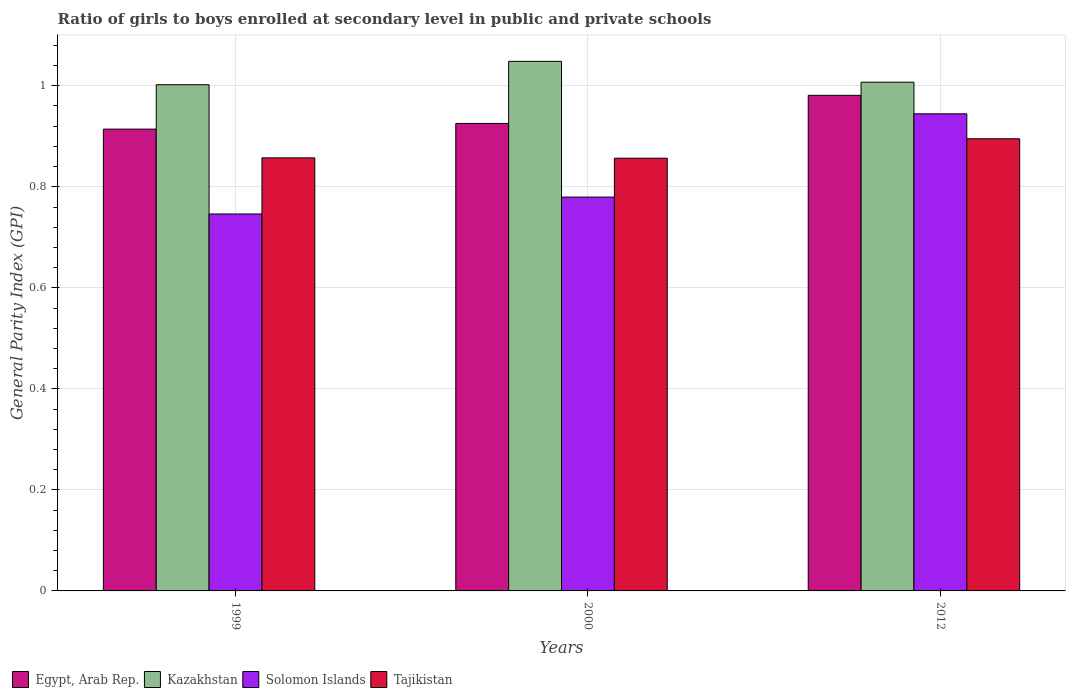Are the number of bars on each tick of the X-axis equal?
Offer a very short reply. Yes. What is the general parity index in Tajikistan in 2000?
Offer a very short reply. 0.86. Across all years, what is the maximum general parity index in Egypt, Arab Rep.?
Give a very brief answer. 0.98. Across all years, what is the minimum general parity index in Tajikistan?
Give a very brief answer. 0.86. In which year was the general parity index in Kazakhstan maximum?
Provide a short and direct response. 2000. In which year was the general parity index in Solomon Islands minimum?
Your response must be concise. 1999. What is the total general parity index in Tajikistan in the graph?
Your answer should be compact. 2.61. What is the difference between the general parity index in Egypt, Arab Rep. in 2000 and that in 2012?
Provide a succinct answer. -0.06. What is the difference between the general parity index in Egypt, Arab Rep. in 2000 and the general parity index in Solomon Islands in 1999?
Provide a short and direct response. 0.18. What is the average general parity index in Tajikistan per year?
Ensure brevity in your answer.  0.87. In the year 2000, what is the difference between the general parity index in Solomon Islands and general parity index in Tajikistan?
Offer a terse response. -0.08. What is the ratio of the general parity index in Egypt, Arab Rep. in 2000 to that in 2012?
Offer a very short reply. 0.94. Is the difference between the general parity index in Solomon Islands in 1999 and 2000 greater than the difference between the general parity index in Tajikistan in 1999 and 2000?
Your answer should be compact. No. What is the difference between the highest and the second highest general parity index in Tajikistan?
Ensure brevity in your answer.  0.04. What is the difference between the highest and the lowest general parity index in Solomon Islands?
Keep it short and to the point. 0.2. In how many years, is the general parity index in Kazakhstan greater than the average general parity index in Kazakhstan taken over all years?
Provide a succinct answer. 1. Is the sum of the general parity index in Tajikistan in 1999 and 2012 greater than the maximum general parity index in Solomon Islands across all years?
Provide a succinct answer. Yes. What does the 2nd bar from the left in 2000 represents?
Offer a very short reply. Kazakhstan. What does the 3rd bar from the right in 2012 represents?
Make the answer very short. Kazakhstan. Is it the case that in every year, the sum of the general parity index in Egypt, Arab Rep. and general parity index in Solomon Islands is greater than the general parity index in Kazakhstan?
Provide a succinct answer. Yes. Are the values on the major ticks of Y-axis written in scientific E-notation?
Offer a very short reply. No. Where does the legend appear in the graph?
Keep it short and to the point. Bottom left. How many legend labels are there?
Give a very brief answer. 4. How are the legend labels stacked?
Give a very brief answer. Horizontal. What is the title of the graph?
Your answer should be very brief. Ratio of girls to boys enrolled at secondary level in public and private schools. Does "Nepal" appear as one of the legend labels in the graph?
Ensure brevity in your answer.  No. What is the label or title of the X-axis?
Provide a succinct answer. Years. What is the label or title of the Y-axis?
Offer a terse response. General Parity Index (GPI). What is the General Parity Index (GPI) of Egypt, Arab Rep. in 1999?
Offer a very short reply. 0.91. What is the General Parity Index (GPI) in Kazakhstan in 1999?
Provide a succinct answer. 1. What is the General Parity Index (GPI) in Solomon Islands in 1999?
Your answer should be very brief. 0.75. What is the General Parity Index (GPI) of Tajikistan in 1999?
Provide a short and direct response. 0.86. What is the General Parity Index (GPI) of Egypt, Arab Rep. in 2000?
Your answer should be compact. 0.93. What is the General Parity Index (GPI) of Kazakhstan in 2000?
Provide a succinct answer. 1.05. What is the General Parity Index (GPI) in Solomon Islands in 2000?
Provide a succinct answer. 0.78. What is the General Parity Index (GPI) of Tajikistan in 2000?
Keep it short and to the point. 0.86. What is the General Parity Index (GPI) of Egypt, Arab Rep. in 2012?
Your answer should be compact. 0.98. What is the General Parity Index (GPI) of Kazakhstan in 2012?
Offer a terse response. 1.01. What is the General Parity Index (GPI) in Solomon Islands in 2012?
Give a very brief answer. 0.94. What is the General Parity Index (GPI) of Tajikistan in 2012?
Your answer should be compact. 0.9. Across all years, what is the maximum General Parity Index (GPI) of Egypt, Arab Rep.?
Provide a short and direct response. 0.98. Across all years, what is the maximum General Parity Index (GPI) in Kazakhstan?
Ensure brevity in your answer.  1.05. Across all years, what is the maximum General Parity Index (GPI) of Solomon Islands?
Provide a succinct answer. 0.94. Across all years, what is the maximum General Parity Index (GPI) of Tajikistan?
Make the answer very short. 0.9. Across all years, what is the minimum General Parity Index (GPI) in Egypt, Arab Rep.?
Offer a very short reply. 0.91. Across all years, what is the minimum General Parity Index (GPI) in Kazakhstan?
Give a very brief answer. 1. Across all years, what is the minimum General Parity Index (GPI) in Solomon Islands?
Offer a terse response. 0.75. Across all years, what is the minimum General Parity Index (GPI) of Tajikistan?
Give a very brief answer. 0.86. What is the total General Parity Index (GPI) of Egypt, Arab Rep. in the graph?
Your answer should be very brief. 2.82. What is the total General Parity Index (GPI) of Kazakhstan in the graph?
Offer a terse response. 3.06. What is the total General Parity Index (GPI) of Solomon Islands in the graph?
Provide a succinct answer. 2.47. What is the total General Parity Index (GPI) in Tajikistan in the graph?
Give a very brief answer. 2.61. What is the difference between the General Parity Index (GPI) of Egypt, Arab Rep. in 1999 and that in 2000?
Provide a short and direct response. -0.01. What is the difference between the General Parity Index (GPI) in Kazakhstan in 1999 and that in 2000?
Provide a short and direct response. -0.05. What is the difference between the General Parity Index (GPI) of Solomon Islands in 1999 and that in 2000?
Your answer should be compact. -0.03. What is the difference between the General Parity Index (GPI) of Tajikistan in 1999 and that in 2000?
Your response must be concise. 0. What is the difference between the General Parity Index (GPI) of Egypt, Arab Rep. in 1999 and that in 2012?
Keep it short and to the point. -0.07. What is the difference between the General Parity Index (GPI) in Kazakhstan in 1999 and that in 2012?
Keep it short and to the point. -0.01. What is the difference between the General Parity Index (GPI) in Solomon Islands in 1999 and that in 2012?
Your answer should be very brief. -0.2. What is the difference between the General Parity Index (GPI) in Tajikistan in 1999 and that in 2012?
Give a very brief answer. -0.04. What is the difference between the General Parity Index (GPI) of Egypt, Arab Rep. in 2000 and that in 2012?
Give a very brief answer. -0.06. What is the difference between the General Parity Index (GPI) of Kazakhstan in 2000 and that in 2012?
Make the answer very short. 0.04. What is the difference between the General Parity Index (GPI) in Solomon Islands in 2000 and that in 2012?
Give a very brief answer. -0.16. What is the difference between the General Parity Index (GPI) in Tajikistan in 2000 and that in 2012?
Your response must be concise. -0.04. What is the difference between the General Parity Index (GPI) of Egypt, Arab Rep. in 1999 and the General Parity Index (GPI) of Kazakhstan in 2000?
Make the answer very short. -0.13. What is the difference between the General Parity Index (GPI) in Egypt, Arab Rep. in 1999 and the General Parity Index (GPI) in Solomon Islands in 2000?
Provide a succinct answer. 0.13. What is the difference between the General Parity Index (GPI) of Egypt, Arab Rep. in 1999 and the General Parity Index (GPI) of Tajikistan in 2000?
Your answer should be very brief. 0.06. What is the difference between the General Parity Index (GPI) of Kazakhstan in 1999 and the General Parity Index (GPI) of Solomon Islands in 2000?
Your answer should be compact. 0.22. What is the difference between the General Parity Index (GPI) in Kazakhstan in 1999 and the General Parity Index (GPI) in Tajikistan in 2000?
Give a very brief answer. 0.15. What is the difference between the General Parity Index (GPI) of Solomon Islands in 1999 and the General Parity Index (GPI) of Tajikistan in 2000?
Your answer should be very brief. -0.11. What is the difference between the General Parity Index (GPI) of Egypt, Arab Rep. in 1999 and the General Parity Index (GPI) of Kazakhstan in 2012?
Provide a succinct answer. -0.09. What is the difference between the General Parity Index (GPI) of Egypt, Arab Rep. in 1999 and the General Parity Index (GPI) of Solomon Islands in 2012?
Your response must be concise. -0.03. What is the difference between the General Parity Index (GPI) of Egypt, Arab Rep. in 1999 and the General Parity Index (GPI) of Tajikistan in 2012?
Ensure brevity in your answer.  0.02. What is the difference between the General Parity Index (GPI) in Kazakhstan in 1999 and the General Parity Index (GPI) in Solomon Islands in 2012?
Offer a terse response. 0.06. What is the difference between the General Parity Index (GPI) of Kazakhstan in 1999 and the General Parity Index (GPI) of Tajikistan in 2012?
Ensure brevity in your answer.  0.11. What is the difference between the General Parity Index (GPI) in Solomon Islands in 1999 and the General Parity Index (GPI) in Tajikistan in 2012?
Provide a succinct answer. -0.15. What is the difference between the General Parity Index (GPI) in Egypt, Arab Rep. in 2000 and the General Parity Index (GPI) in Kazakhstan in 2012?
Make the answer very short. -0.08. What is the difference between the General Parity Index (GPI) of Egypt, Arab Rep. in 2000 and the General Parity Index (GPI) of Solomon Islands in 2012?
Your answer should be compact. -0.02. What is the difference between the General Parity Index (GPI) of Egypt, Arab Rep. in 2000 and the General Parity Index (GPI) of Tajikistan in 2012?
Ensure brevity in your answer.  0.03. What is the difference between the General Parity Index (GPI) of Kazakhstan in 2000 and the General Parity Index (GPI) of Solomon Islands in 2012?
Your answer should be compact. 0.1. What is the difference between the General Parity Index (GPI) of Kazakhstan in 2000 and the General Parity Index (GPI) of Tajikistan in 2012?
Provide a short and direct response. 0.15. What is the difference between the General Parity Index (GPI) of Solomon Islands in 2000 and the General Parity Index (GPI) of Tajikistan in 2012?
Ensure brevity in your answer.  -0.12. What is the average General Parity Index (GPI) of Egypt, Arab Rep. per year?
Provide a succinct answer. 0.94. What is the average General Parity Index (GPI) in Kazakhstan per year?
Ensure brevity in your answer.  1.02. What is the average General Parity Index (GPI) in Solomon Islands per year?
Your response must be concise. 0.82. What is the average General Parity Index (GPI) in Tajikistan per year?
Provide a succinct answer. 0.87. In the year 1999, what is the difference between the General Parity Index (GPI) in Egypt, Arab Rep. and General Parity Index (GPI) in Kazakhstan?
Your answer should be compact. -0.09. In the year 1999, what is the difference between the General Parity Index (GPI) in Egypt, Arab Rep. and General Parity Index (GPI) in Solomon Islands?
Provide a succinct answer. 0.17. In the year 1999, what is the difference between the General Parity Index (GPI) of Egypt, Arab Rep. and General Parity Index (GPI) of Tajikistan?
Keep it short and to the point. 0.06. In the year 1999, what is the difference between the General Parity Index (GPI) of Kazakhstan and General Parity Index (GPI) of Solomon Islands?
Your response must be concise. 0.26. In the year 1999, what is the difference between the General Parity Index (GPI) in Kazakhstan and General Parity Index (GPI) in Tajikistan?
Your response must be concise. 0.14. In the year 1999, what is the difference between the General Parity Index (GPI) of Solomon Islands and General Parity Index (GPI) of Tajikistan?
Give a very brief answer. -0.11. In the year 2000, what is the difference between the General Parity Index (GPI) in Egypt, Arab Rep. and General Parity Index (GPI) in Kazakhstan?
Your response must be concise. -0.12. In the year 2000, what is the difference between the General Parity Index (GPI) of Egypt, Arab Rep. and General Parity Index (GPI) of Solomon Islands?
Your response must be concise. 0.15. In the year 2000, what is the difference between the General Parity Index (GPI) of Egypt, Arab Rep. and General Parity Index (GPI) of Tajikistan?
Give a very brief answer. 0.07. In the year 2000, what is the difference between the General Parity Index (GPI) of Kazakhstan and General Parity Index (GPI) of Solomon Islands?
Give a very brief answer. 0.27. In the year 2000, what is the difference between the General Parity Index (GPI) of Kazakhstan and General Parity Index (GPI) of Tajikistan?
Give a very brief answer. 0.19. In the year 2000, what is the difference between the General Parity Index (GPI) in Solomon Islands and General Parity Index (GPI) in Tajikistan?
Give a very brief answer. -0.08. In the year 2012, what is the difference between the General Parity Index (GPI) of Egypt, Arab Rep. and General Parity Index (GPI) of Kazakhstan?
Offer a very short reply. -0.03. In the year 2012, what is the difference between the General Parity Index (GPI) in Egypt, Arab Rep. and General Parity Index (GPI) in Solomon Islands?
Your answer should be compact. 0.04. In the year 2012, what is the difference between the General Parity Index (GPI) in Egypt, Arab Rep. and General Parity Index (GPI) in Tajikistan?
Your response must be concise. 0.09. In the year 2012, what is the difference between the General Parity Index (GPI) in Kazakhstan and General Parity Index (GPI) in Solomon Islands?
Provide a short and direct response. 0.06. In the year 2012, what is the difference between the General Parity Index (GPI) in Kazakhstan and General Parity Index (GPI) in Tajikistan?
Offer a very short reply. 0.11. In the year 2012, what is the difference between the General Parity Index (GPI) of Solomon Islands and General Parity Index (GPI) of Tajikistan?
Offer a terse response. 0.05. What is the ratio of the General Parity Index (GPI) of Egypt, Arab Rep. in 1999 to that in 2000?
Offer a very short reply. 0.99. What is the ratio of the General Parity Index (GPI) of Kazakhstan in 1999 to that in 2000?
Offer a terse response. 0.96. What is the ratio of the General Parity Index (GPI) of Solomon Islands in 1999 to that in 2000?
Ensure brevity in your answer.  0.96. What is the ratio of the General Parity Index (GPI) of Tajikistan in 1999 to that in 2000?
Offer a terse response. 1. What is the ratio of the General Parity Index (GPI) of Egypt, Arab Rep. in 1999 to that in 2012?
Offer a terse response. 0.93. What is the ratio of the General Parity Index (GPI) in Solomon Islands in 1999 to that in 2012?
Give a very brief answer. 0.79. What is the ratio of the General Parity Index (GPI) of Tajikistan in 1999 to that in 2012?
Offer a very short reply. 0.96. What is the ratio of the General Parity Index (GPI) in Egypt, Arab Rep. in 2000 to that in 2012?
Your response must be concise. 0.94. What is the ratio of the General Parity Index (GPI) of Kazakhstan in 2000 to that in 2012?
Make the answer very short. 1.04. What is the ratio of the General Parity Index (GPI) of Solomon Islands in 2000 to that in 2012?
Keep it short and to the point. 0.83. What is the ratio of the General Parity Index (GPI) of Tajikistan in 2000 to that in 2012?
Your answer should be compact. 0.96. What is the difference between the highest and the second highest General Parity Index (GPI) of Egypt, Arab Rep.?
Your response must be concise. 0.06. What is the difference between the highest and the second highest General Parity Index (GPI) in Kazakhstan?
Provide a succinct answer. 0.04. What is the difference between the highest and the second highest General Parity Index (GPI) in Solomon Islands?
Provide a succinct answer. 0.16. What is the difference between the highest and the second highest General Parity Index (GPI) in Tajikistan?
Keep it short and to the point. 0.04. What is the difference between the highest and the lowest General Parity Index (GPI) in Egypt, Arab Rep.?
Offer a terse response. 0.07. What is the difference between the highest and the lowest General Parity Index (GPI) in Kazakhstan?
Provide a short and direct response. 0.05. What is the difference between the highest and the lowest General Parity Index (GPI) of Solomon Islands?
Make the answer very short. 0.2. What is the difference between the highest and the lowest General Parity Index (GPI) of Tajikistan?
Provide a short and direct response. 0.04. 